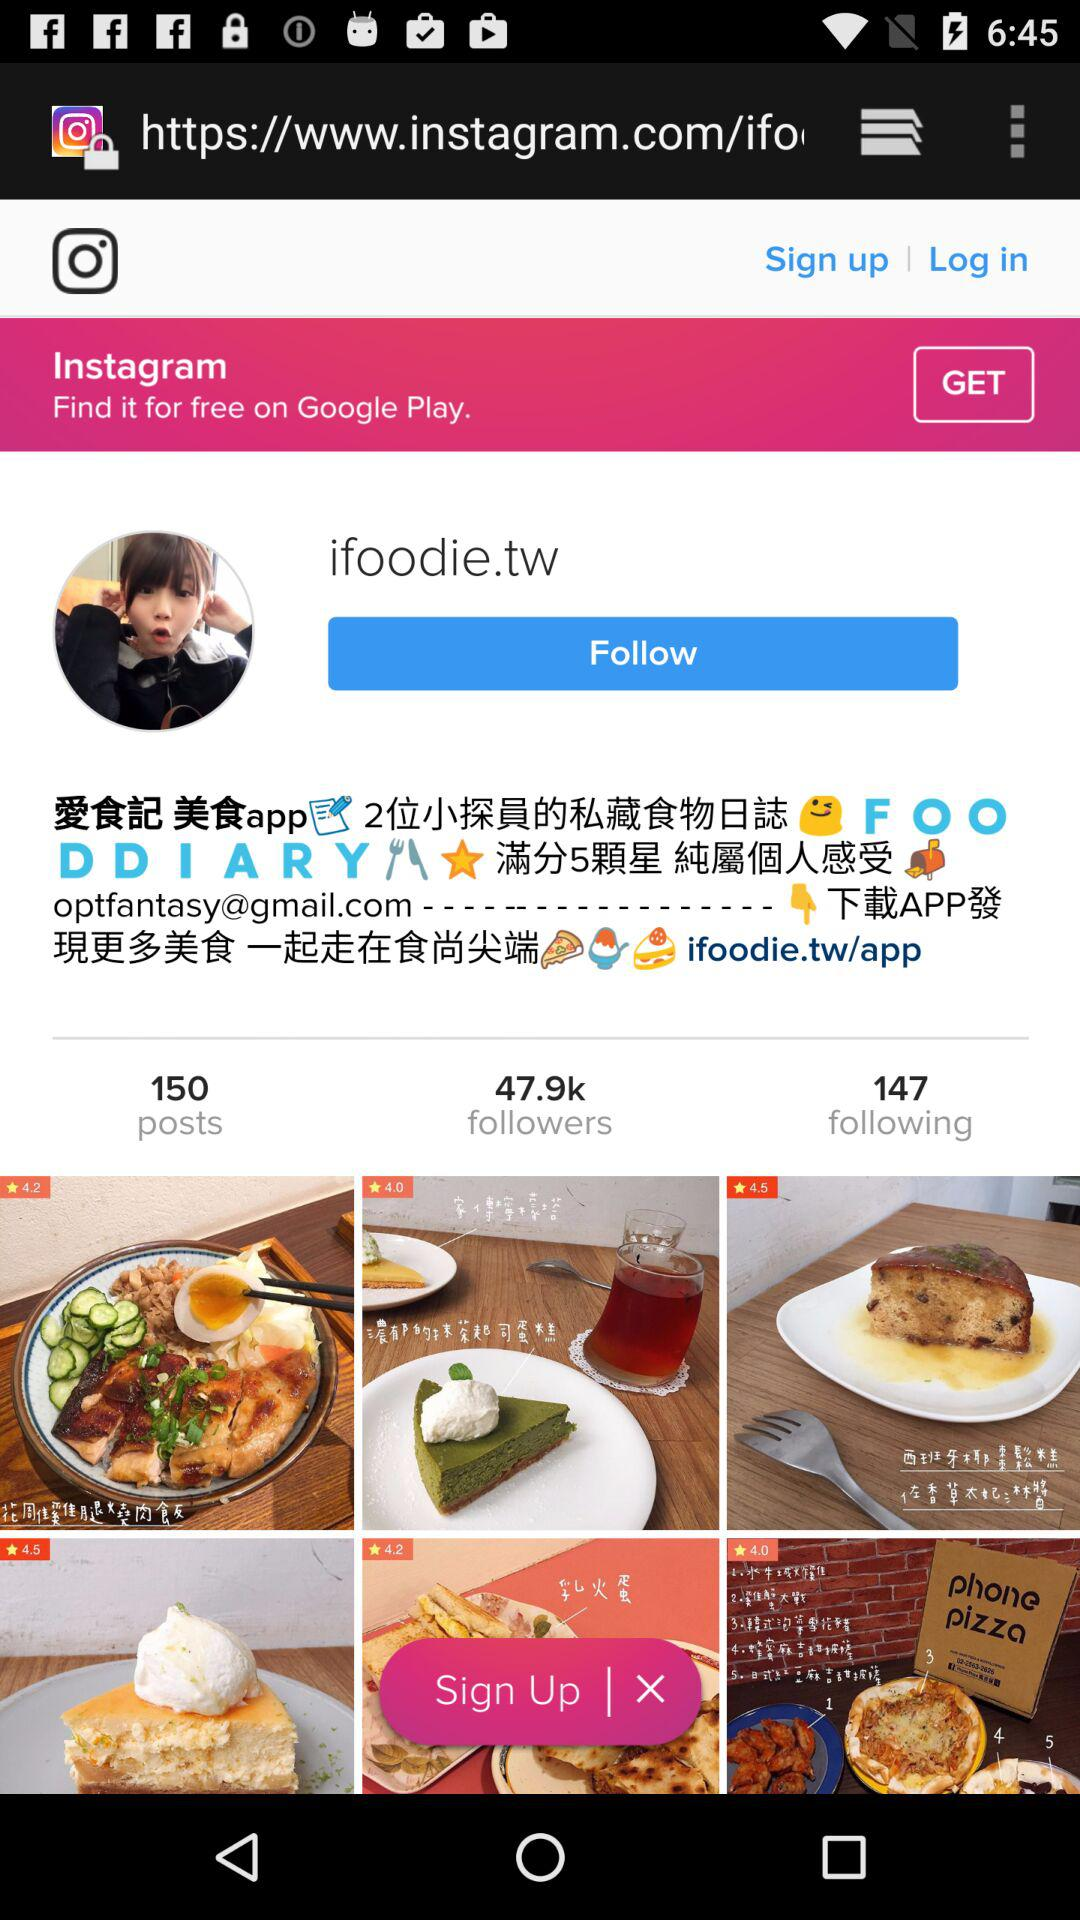How many posts are there? There are 150 posts. 